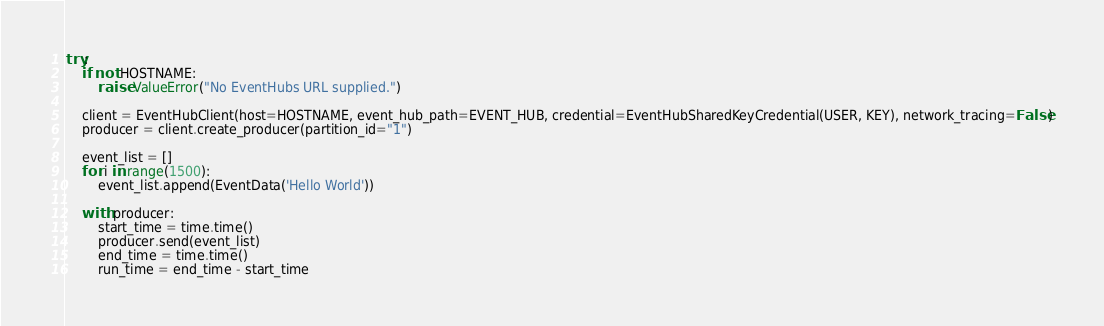Convert code to text. <code><loc_0><loc_0><loc_500><loc_500><_Python_>

try:
    if not HOSTNAME:
        raise ValueError("No EventHubs URL supplied.")

    client = EventHubClient(host=HOSTNAME, event_hub_path=EVENT_HUB, credential=EventHubSharedKeyCredential(USER, KEY), network_tracing=False)
    producer = client.create_producer(partition_id="1")

    event_list = []
    for i in range(1500):
        event_list.append(EventData('Hello World'))

    with producer:
        start_time = time.time()
        producer.send(event_list)
        end_time = time.time()
        run_time = end_time - start_time</code> 